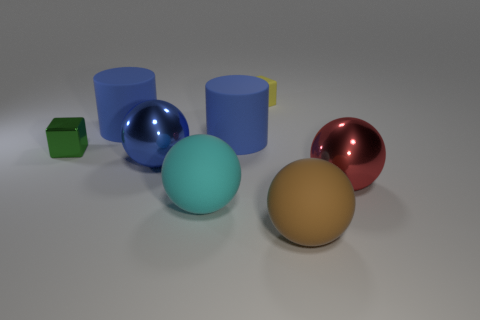What is the color of the big thing right of the brown thing that is in front of the yellow object?
Offer a very short reply. Red. Is there a tiny red metal thing?
Offer a terse response. No. There is a big thing that is on the right side of the yellow rubber thing and behind the large brown rubber thing; what color is it?
Offer a terse response. Red. Does the blue object left of the large blue metallic thing have the same size as the blue cylinder on the right side of the cyan sphere?
Offer a very short reply. Yes. How many other things are there of the same size as the cyan ball?
Your answer should be very brief. 5. There is a matte ball behind the brown object; how many blue rubber cylinders are to the left of it?
Offer a very short reply. 1. Is the number of large matte objects behind the large brown sphere less than the number of blue matte objects?
Keep it short and to the point. No. What is the shape of the blue object that is in front of the thing to the left of the blue rubber object that is to the left of the large blue ball?
Your answer should be compact. Sphere. Is the green thing the same shape as the big brown rubber object?
Offer a very short reply. No. How many other things are the same shape as the tiny yellow object?
Offer a terse response. 1. 